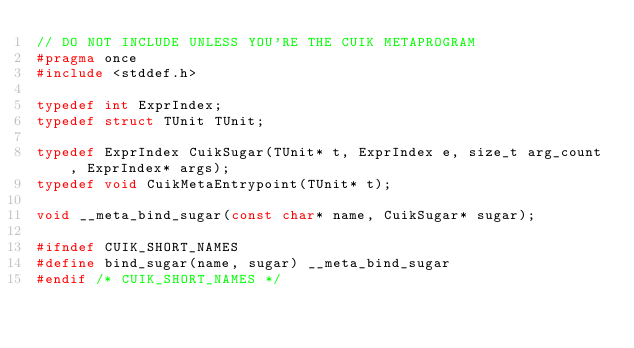<code> <loc_0><loc_0><loc_500><loc_500><_C_>// DO NOT INCLUDE UNLESS YOU'RE THE CUIK METAPROGRAM 
#pragma once
#include <stddef.h>

typedef int ExprIndex;
typedef struct TUnit TUnit;

typedef ExprIndex CuikSugar(TUnit* t, ExprIndex e, size_t arg_count, ExprIndex* args);
typedef void CuikMetaEntrypoint(TUnit* t);

void __meta_bind_sugar(const char* name, CuikSugar* sugar);

#ifndef CUIK_SHORT_NAMES
#define bind_sugar(name, sugar) __meta_bind_sugar
#endif /* CUIK_SHORT_NAMES */
</code> 